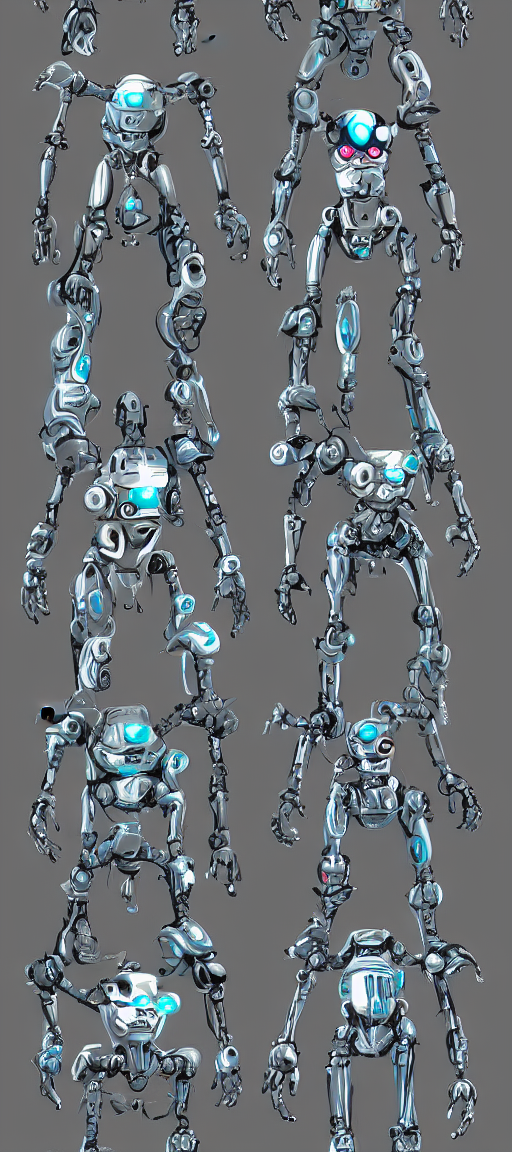How could these robots be utilized in a real-world scenario? Given their humanoid form and dexterity, these robots could be employed in various settings such as manufacturing for tasks requiring precision, in healthcare as assistive devices for surgery or patient care, and in exploration missions where human presence might be risky, like space exploration or deep-sea ventures. Their sophisticated design suggests advanced capabilities, making them versatile for many applications. 